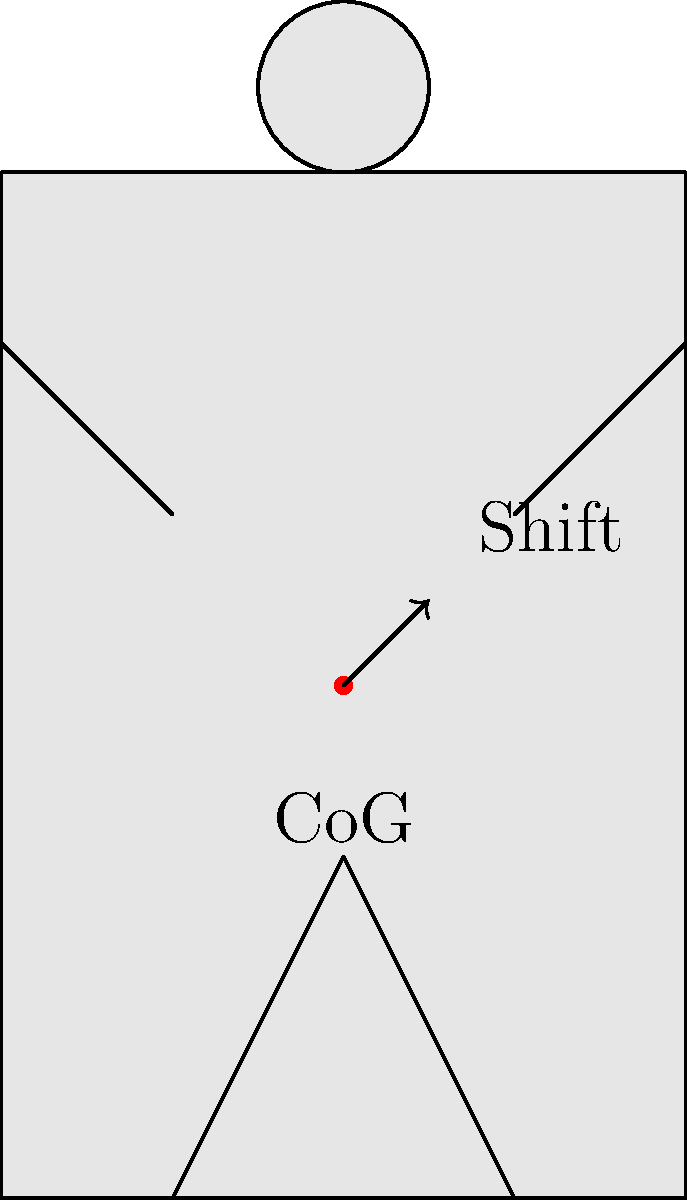During a wrestling bridge maneuver, the center of gravity (CoG) of a wrestler shifts. In which direction does the CoG typically move, and why is this shift important for maintaining stability? To understand the shift in the center of gravity during a wrestling bridge maneuver, let's break it down step-by-step:

1. Initial position: In a neutral standing position, a wrestler's CoG is typically located near the center of their body, around the lower abdomen.

2. Bridge formation: As the wrestler arches their back to form the bridge, several changes occur:
   a. The hips elevate
   b. The head and shoulders remain in contact with the mat
   c. The chest expands upward

3. CoG shift: These changes cause the CoG to shift:
   a. Upward: Due to the overall elevation of the body
   b. Slightly backward: Towards the head, as more body mass is distributed in that direction

4. Importance of the shift:
   a. Stability: The backward shift helps counterbalance the forward force exerted by an opponent
   b. Leverage: It allows the wrestler to exert more force through their legs and core
   c. Resistance: Makes it harder for an opponent to push the wrestler's shoulders down to the mat

5. Mathematical representation:
   Let the initial CoG be at point $(x_0, y_0, z_0)$ and the final CoG be at $(x_1, y_1, z_1)$
   The shift can be represented as a vector:
   $$\vec{v} = (x_1 - x_0, y_1 - y_0, z_1 - z_0)$$
   Where $z_1 > z_0$ (upward shift) and $x_1 < x_0$ (backward shift)

6. Biomechanical advantage:
   The shifted CoG creates a moment arm that helps resist the opponent's force:
   $$\text{Moment} = F \times d$$
   Where $F$ is the wrestler's resistive force and $d$ is the perpendicular distance from the line of action of the force to the point of rotation (typically the shoulders or head in contact with the mat).

This shift in CoG is crucial for maintaining stability and creating a mechanical advantage during the wrestling bridge maneuver.
Answer: Upward and slightly backward; improves stability and leverage against opponent's force. 